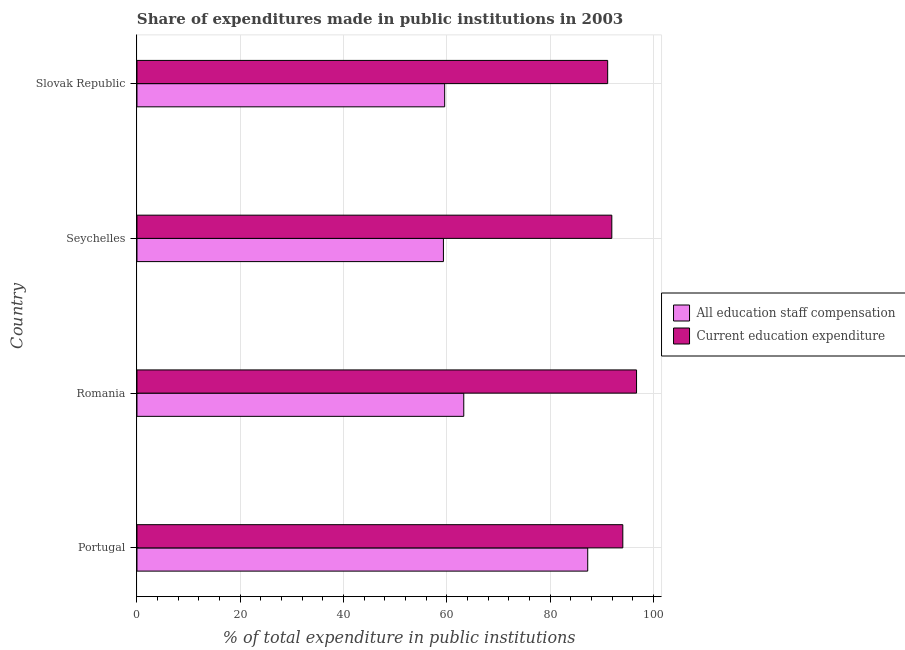How many different coloured bars are there?
Provide a succinct answer. 2. What is the expenditure in staff compensation in Seychelles?
Offer a very short reply. 59.33. Across all countries, what is the maximum expenditure in staff compensation?
Your answer should be very brief. 87.26. Across all countries, what is the minimum expenditure in staff compensation?
Your answer should be compact. 59.33. In which country was the expenditure in staff compensation minimum?
Offer a terse response. Seychelles. What is the total expenditure in education in the graph?
Ensure brevity in your answer.  373.81. What is the difference between the expenditure in education in Seychelles and that in Slovak Republic?
Your answer should be very brief. 0.8. What is the difference between the expenditure in staff compensation in Romania and the expenditure in education in Portugal?
Ensure brevity in your answer.  -30.79. What is the average expenditure in education per country?
Offer a very short reply. 93.45. What is the difference between the expenditure in staff compensation and expenditure in education in Seychelles?
Offer a very short reply. -32.6. What is the ratio of the expenditure in staff compensation in Romania to that in Seychelles?
Make the answer very short. 1.07. Is the difference between the expenditure in staff compensation in Seychelles and Slovak Republic greater than the difference between the expenditure in education in Seychelles and Slovak Republic?
Your response must be concise. No. What is the difference between the highest and the second highest expenditure in staff compensation?
Your response must be concise. 23.99. What is the difference between the highest and the lowest expenditure in education?
Offer a very short reply. 5.59. In how many countries, is the expenditure in staff compensation greater than the average expenditure in staff compensation taken over all countries?
Keep it short and to the point. 1. Is the sum of the expenditure in education in Portugal and Slovak Republic greater than the maximum expenditure in staff compensation across all countries?
Provide a succinct answer. Yes. What does the 2nd bar from the top in Slovak Republic represents?
Your answer should be very brief. All education staff compensation. What does the 1st bar from the bottom in Portugal represents?
Keep it short and to the point. All education staff compensation. Are all the bars in the graph horizontal?
Your response must be concise. Yes. Are the values on the major ticks of X-axis written in scientific E-notation?
Provide a succinct answer. No. Where does the legend appear in the graph?
Your answer should be very brief. Center right. How are the legend labels stacked?
Provide a short and direct response. Vertical. What is the title of the graph?
Your answer should be compact. Share of expenditures made in public institutions in 2003. Does "Taxes on exports" appear as one of the legend labels in the graph?
Your answer should be compact. No. What is the label or title of the X-axis?
Ensure brevity in your answer.  % of total expenditure in public institutions. What is the % of total expenditure in public institutions in All education staff compensation in Portugal?
Offer a terse response. 87.26. What is the % of total expenditure in public institutions of Current education expenditure in Portugal?
Your answer should be very brief. 94.05. What is the % of total expenditure in public institutions in All education staff compensation in Romania?
Offer a terse response. 63.27. What is the % of total expenditure in public institutions of Current education expenditure in Romania?
Your answer should be very brief. 96.71. What is the % of total expenditure in public institutions in All education staff compensation in Seychelles?
Keep it short and to the point. 59.33. What is the % of total expenditure in public institutions in Current education expenditure in Seychelles?
Give a very brief answer. 91.92. What is the % of total expenditure in public institutions in All education staff compensation in Slovak Republic?
Provide a short and direct response. 59.57. What is the % of total expenditure in public institutions in Current education expenditure in Slovak Republic?
Ensure brevity in your answer.  91.12. Across all countries, what is the maximum % of total expenditure in public institutions in All education staff compensation?
Your response must be concise. 87.26. Across all countries, what is the maximum % of total expenditure in public institutions in Current education expenditure?
Your response must be concise. 96.71. Across all countries, what is the minimum % of total expenditure in public institutions of All education staff compensation?
Your response must be concise. 59.33. Across all countries, what is the minimum % of total expenditure in public institutions of Current education expenditure?
Offer a very short reply. 91.12. What is the total % of total expenditure in public institutions in All education staff compensation in the graph?
Your answer should be very brief. 269.41. What is the total % of total expenditure in public institutions in Current education expenditure in the graph?
Give a very brief answer. 373.81. What is the difference between the % of total expenditure in public institutions in All education staff compensation in Portugal and that in Romania?
Offer a terse response. 23.99. What is the difference between the % of total expenditure in public institutions of Current education expenditure in Portugal and that in Romania?
Provide a succinct answer. -2.66. What is the difference between the % of total expenditure in public institutions in All education staff compensation in Portugal and that in Seychelles?
Offer a very short reply. 27.93. What is the difference between the % of total expenditure in public institutions in Current education expenditure in Portugal and that in Seychelles?
Offer a very short reply. 2.13. What is the difference between the % of total expenditure in public institutions of All education staff compensation in Portugal and that in Slovak Republic?
Keep it short and to the point. 27.69. What is the difference between the % of total expenditure in public institutions in Current education expenditure in Portugal and that in Slovak Republic?
Keep it short and to the point. 2.93. What is the difference between the % of total expenditure in public institutions in All education staff compensation in Romania and that in Seychelles?
Give a very brief answer. 3.94. What is the difference between the % of total expenditure in public institutions in Current education expenditure in Romania and that in Seychelles?
Ensure brevity in your answer.  4.79. What is the difference between the % of total expenditure in public institutions of All education staff compensation in Romania and that in Slovak Republic?
Give a very brief answer. 3.7. What is the difference between the % of total expenditure in public institutions of Current education expenditure in Romania and that in Slovak Republic?
Give a very brief answer. 5.59. What is the difference between the % of total expenditure in public institutions in All education staff compensation in Seychelles and that in Slovak Republic?
Keep it short and to the point. -0.24. What is the difference between the % of total expenditure in public institutions of Current education expenditure in Seychelles and that in Slovak Republic?
Give a very brief answer. 0.8. What is the difference between the % of total expenditure in public institutions of All education staff compensation in Portugal and the % of total expenditure in public institutions of Current education expenditure in Romania?
Give a very brief answer. -9.45. What is the difference between the % of total expenditure in public institutions in All education staff compensation in Portugal and the % of total expenditure in public institutions in Current education expenditure in Seychelles?
Your answer should be very brief. -4.66. What is the difference between the % of total expenditure in public institutions in All education staff compensation in Portugal and the % of total expenditure in public institutions in Current education expenditure in Slovak Republic?
Your answer should be very brief. -3.86. What is the difference between the % of total expenditure in public institutions of All education staff compensation in Romania and the % of total expenditure in public institutions of Current education expenditure in Seychelles?
Offer a very short reply. -28.66. What is the difference between the % of total expenditure in public institutions in All education staff compensation in Romania and the % of total expenditure in public institutions in Current education expenditure in Slovak Republic?
Keep it short and to the point. -27.86. What is the difference between the % of total expenditure in public institutions of All education staff compensation in Seychelles and the % of total expenditure in public institutions of Current education expenditure in Slovak Republic?
Offer a terse response. -31.8. What is the average % of total expenditure in public institutions of All education staff compensation per country?
Your answer should be compact. 67.35. What is the average % of total expenditure in public institutions in Current education expenditure per country?
Give a very brief answer. 93.45. What is the difference between the % of total expenditure in public institutions in All education staff compensation and % of total expenditure in public institutions in Current education expenditure in Portugal?
Ensure brevity in your answer.  -6.8. What is the difference between the % of total expenditure in public institutions of All education staff compensation and % of total expenditure in public institutions of Current education expenditure in Romania?
Ensure brevity in your answer.  -33.45. What is the difference between the % of total expenditure in public institutions of All education staff compensation and % of total expenditure in public institutions of Current education expenditure in Seychelles?
Ensure brevity in your answer.  -32.6. What is the difference between the % of total expenditure in public institutions of All education staff compensation and % of total expenditure in public institutions of Current education expenditure in Slovak Republic?
Ensure brevity in your answer.  -31.56. What is the ratio of the % of total expenditure in public institutions of All education staff compensation in Portugal to that in Romania?
Provide a succinct answer. 1.38. What is the ratio of the % of total expenditure in public institutions of Current education expenditure in Portugal to that in Romania?
Your response must be concise. 0.97. What is the ratio of the % of total expenditure in public institutions in All education staff compensation in Portugal to that in Seychelles?
Your response must be concise. 1.47. What is the ratio of the % of total expenditure in public institutions in Current education expenditure in Portugal to that in Seychelles?
Ensure brevity in your answer.  1.02. What is the ratio of the % of total expenditure in public institutions of All education staff compensation in Portugal to that in Slovak Republic?
Keep it short and to the point. 1.46. What is the ratio of the % of total expenditure in public institutions of Current education expenditure in Portugal to that in Slovak Republic?
Your response must be concise. 1.03. What is the ratio of the % of total expenditure in public institutions of All education staff compensation in Romania to that in Seychelles?
Keep it short and to the point. 1.07. What is the ratio of the % of total expenditure in public institutions in Current education expenditure in Romania to that in Seychelles?
Make the answer very short. 1.05. What is the ratio of the % of total expenditure in public institutions in All education staff compensation in Romania to that in Slovak Republic?
Your answer should be compact. 1.06. What is the ratio of the % of total expenditure in public institutions in Current education expenditure in Romania to that in Slovak Republic?
Provide a short and direct response. 1.06. What is the ratio of the % of total expenditure in public institutions of Current education expenditure in Seychelles to that in Slovak Republic?
Provide a succinct answer. 1.01. What is the difference between the highest and the second highest % of total expenditure in public institutions of All education staff compensation?
Give a very brief answer. 23.99. What is the difference between the highest and the second highest % of total expenditure in public institutions of Current education expenditure?
Make the answer very short. 2.66. What is the difference between the highest and the lowest % of total expenditure in public institutions in All education staff compensation?
Ensure brevity in your answer.  27.93. What is the difference between the highest and the lowest % of total expenditure in public institutions in Current education expenditure?
Offer a terse response. 5.59. 